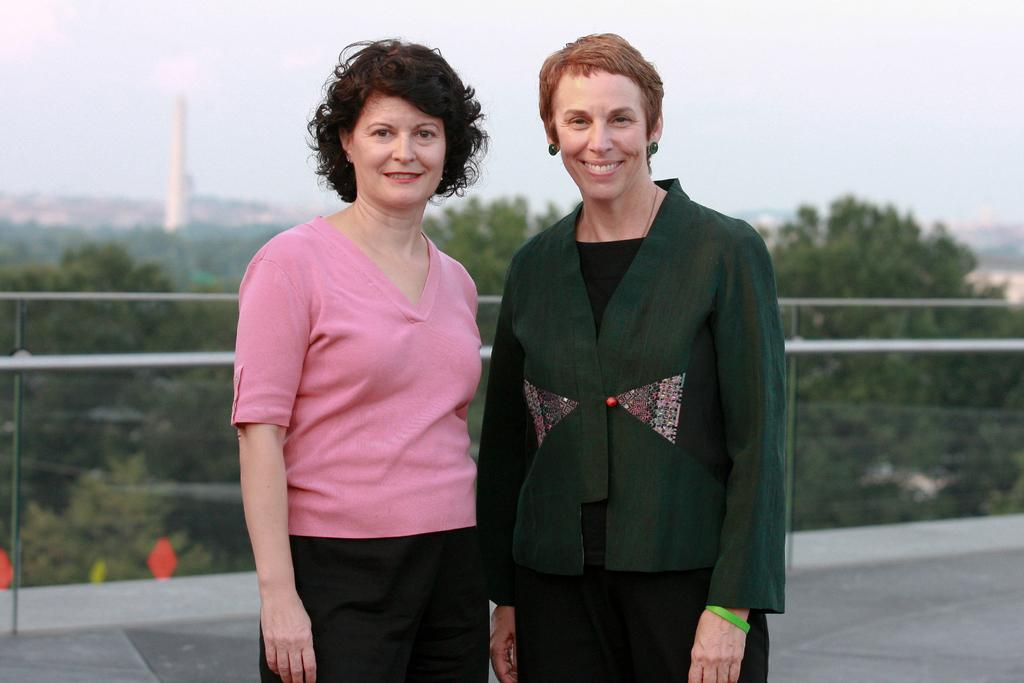How many women are in the image? There are two women in the image. What are the women doing in the image? The women are standing and smiling. What can be seen in the background of the image? There are trees, a tower, and the sky visible in the background of the image. What type of spoon is being used by the women in the image? There is no spoon present in the image. What day of the week is it in the image? The day of the week is not mentioned or depicted in the image. 